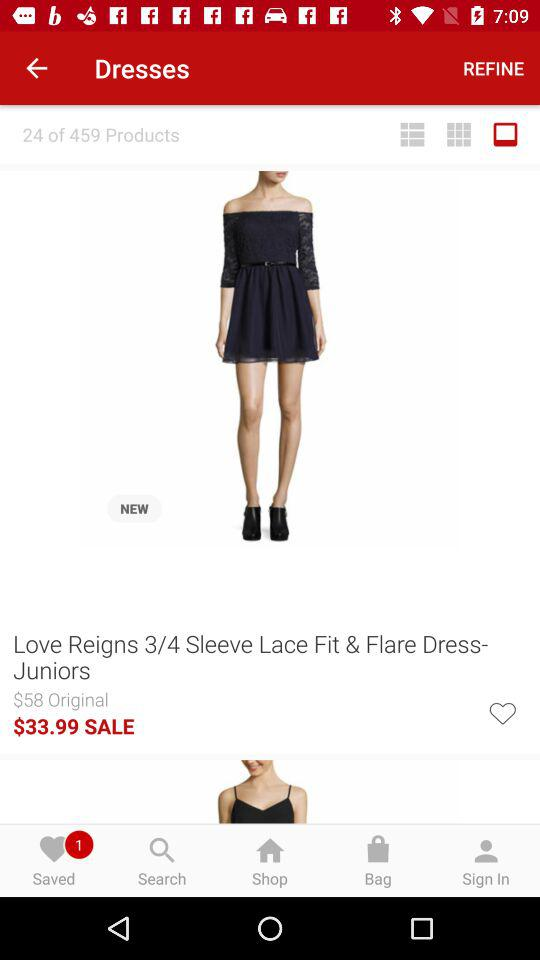What is the original price of the dress? The original price of the dress is $58. 